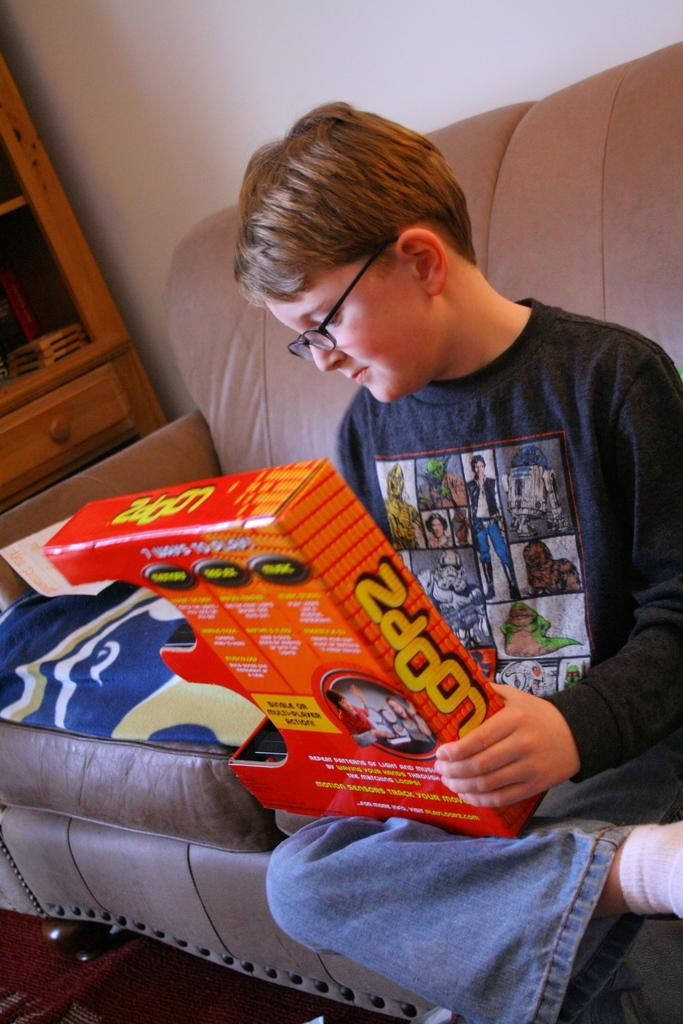Who is the main subject in the image? There is a boy in the image. What is the boy doing in the image? The boy is sitting on a sofa. What is the boy holding in his hand? The boy is holding a box in his hand. What can be seen in the background of the image? There is a wall and a cupboard in the background of the image. What type of hen can be seen in the middle of the image? There is no hen present in the image. What drink is the boy holding in his hand? The boy is holding a box, not a drink, in his hand. 